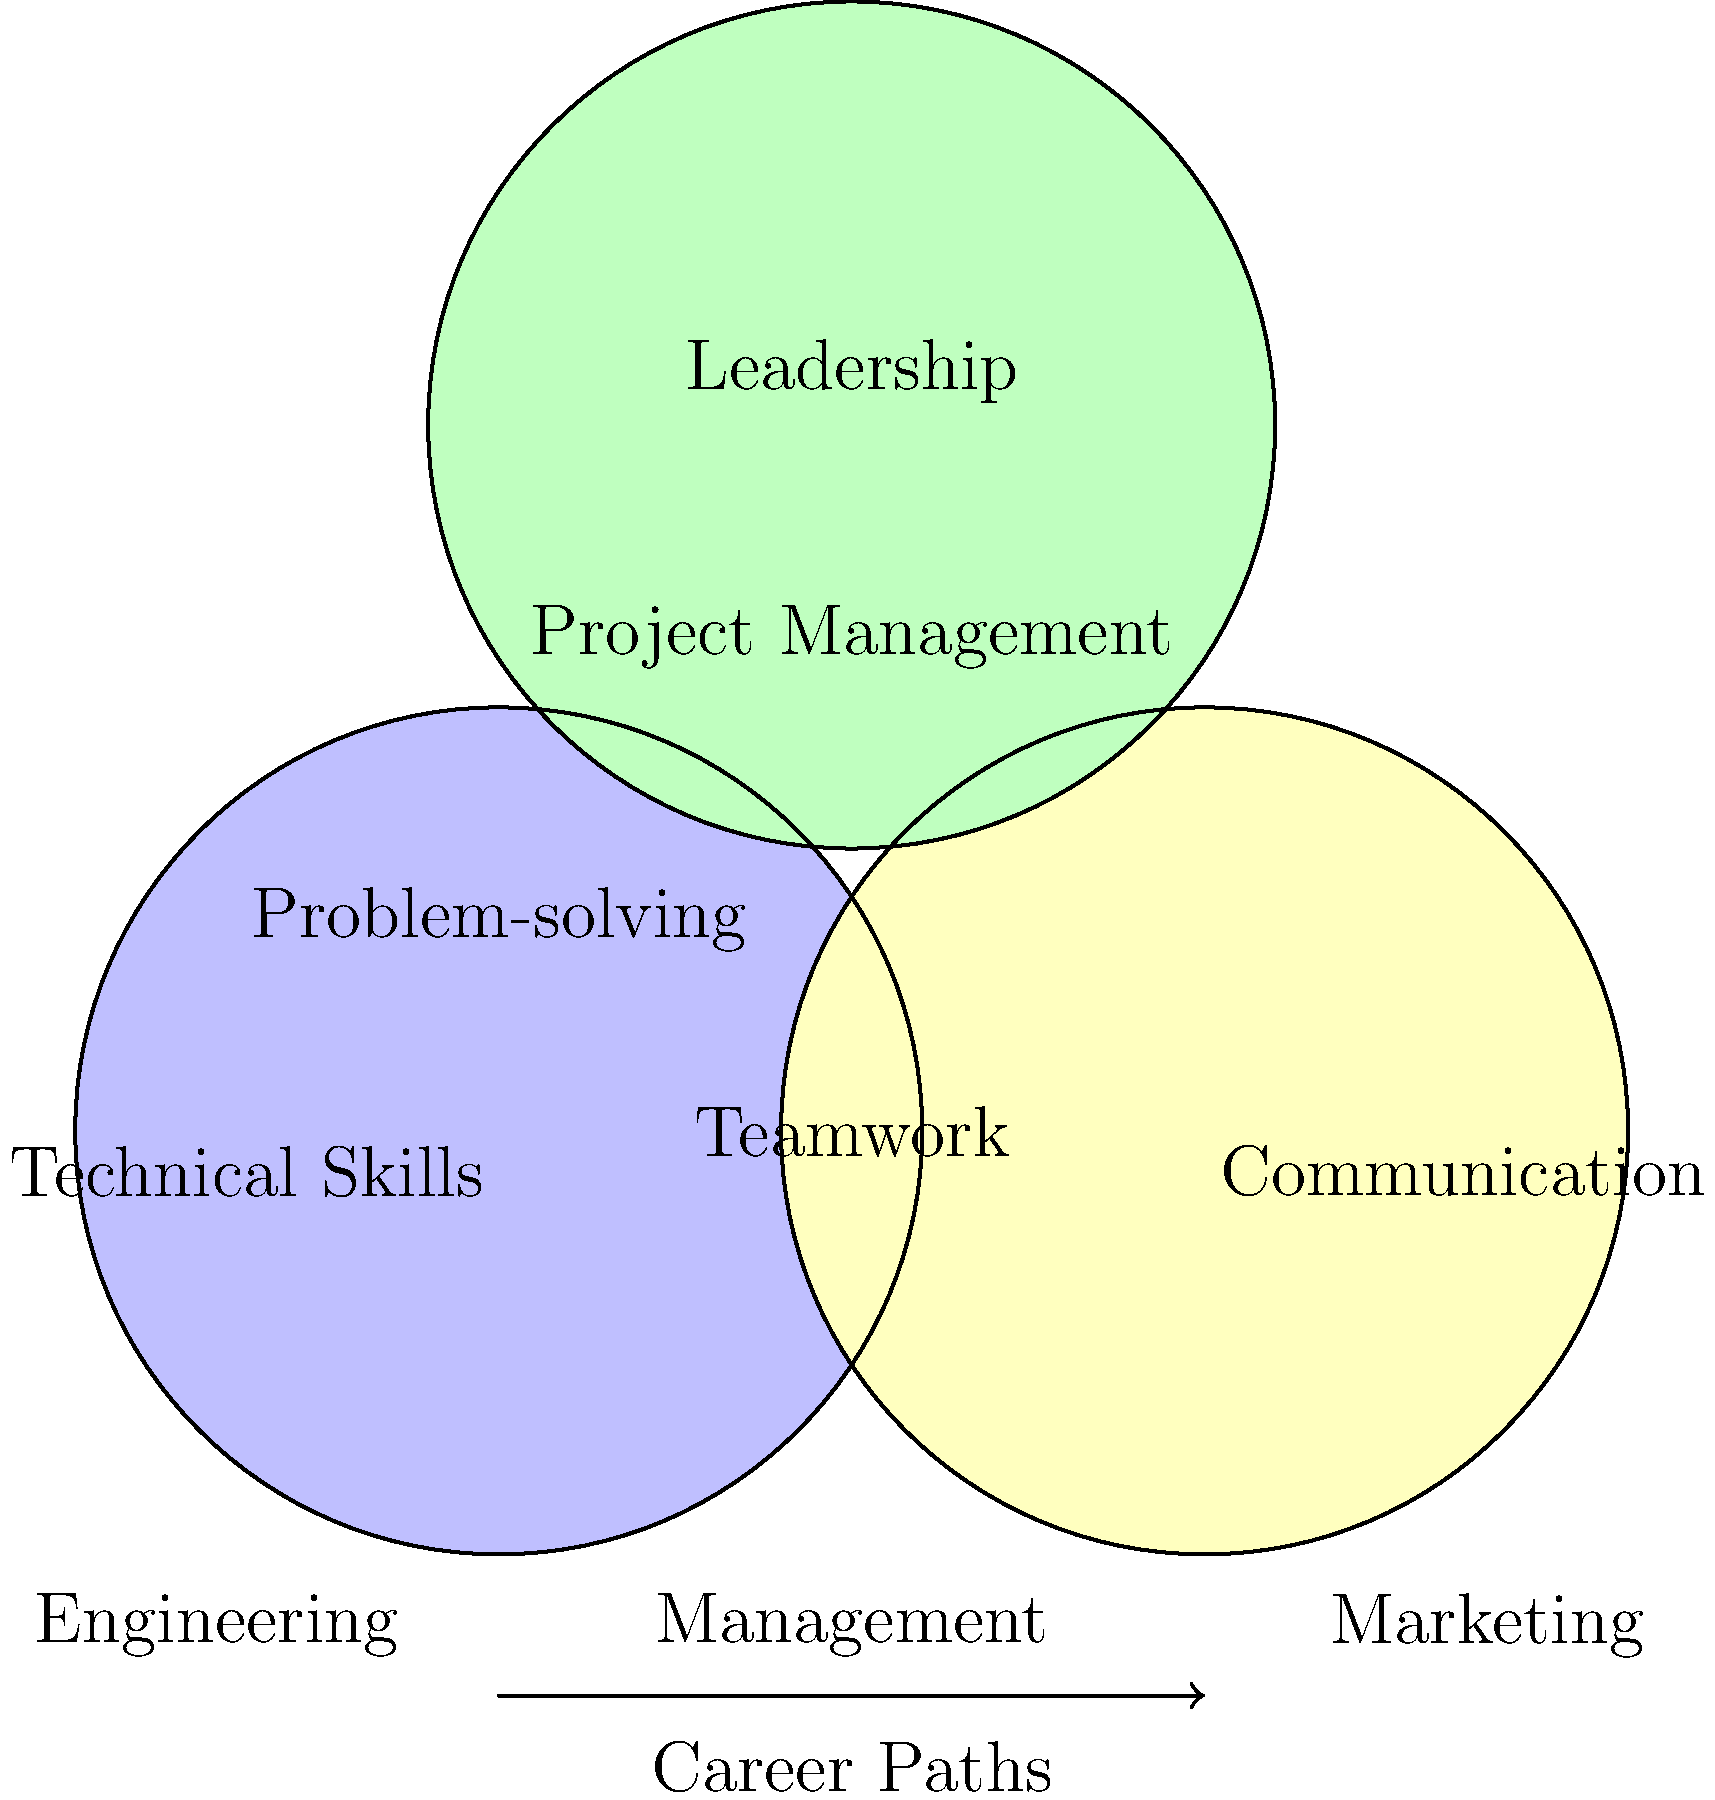Based on the Venn diagram comparing skills for different career paths, which skill set is most crucial for a student interested in pursuing a management career? To determine the most crucial skill set for a management career, let's analyze the Venn diagram:

1. The diagram shows three main skill categories: Technical Skills, Communication, and Leadership.

2. Management is listed at the bottom of the diagram, suggesting it requires a combination of these skills.

3. The overlapping areas of the circles represent skills that are common to multiple categories:
   - Problem-solving (between Technical Skills and Leadership)
   - Teamwork (between Technical Skills and Communication)
   - Project Management (between Communication and Leadership)

4. For a management position, all these skills are important, but the most central and unique skill to management is Leadership.

5. Leadership is at the top of the diagram, suggesting its importance in higher-level positions like management.

6. While communication and technical skills are valuable, leadership skills are what typically distinguish managers from other roles.

Therefore, based on this Venn diagram, the most crucial skill set for a student interested in pursuing a management career would be Leadership skills.
Answer: Leadership skills 